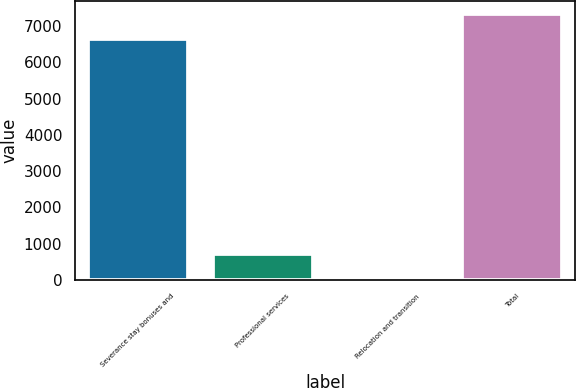Convert chart to OTSL. <chart><loc_0><loc_0><loc_500><loc_500><bar_chart><fcel>Severance stay bonuses and<fcel>Professional services<fcel>Relocation and transition<fcel>Total<nl><fcel>6650<fcel>703<fcel>20<fcel>7333<nl></chart> 